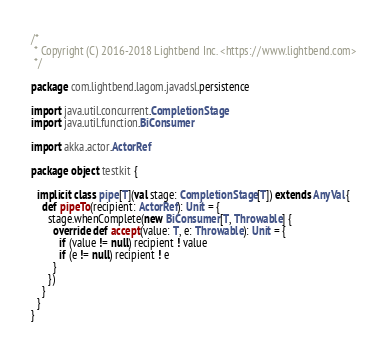<code> <loc_0><loc_0><loc_500><loc_500><_Scala_>/*
 * Copyright (C) 2016-2018 Lightbend Inc. <https://www.lightbend.com>
 */

package com.lightbend.lagom.javadsl.persistence

import java.util.concurrent.CompletionStage
import java.util.function.BiConsumer

import akka.actor.ActorRef

package object testkit {

  implicit class pipe[T](val stage: CompletionStage[T]) extends AnyVal {
    def pipeTo(recipient: ActorRef): Unit = {
      stage.whenComplete(new BiConsumer[T, Throwable] {
        override def accept(value: T, e: Throwable): Unit = {
          if (value != null) recipient ! value
          if (e != null) recipient ! e
        }
      })
    }
  }
}
</code> 